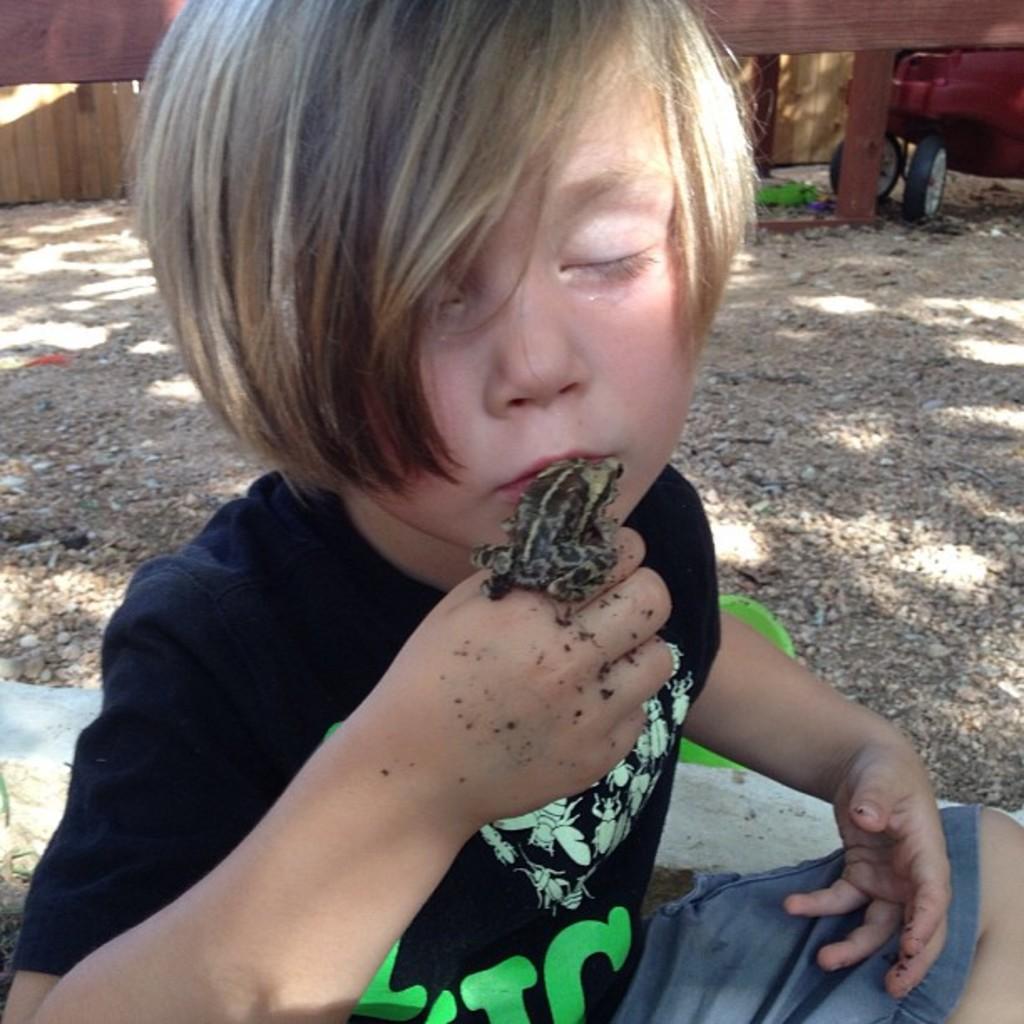How would you summarize this image in a sentence or two? In this picture we can see a boy sitting on the ground with a frog on his hand and in the background we can see a vehicle and the wall. 